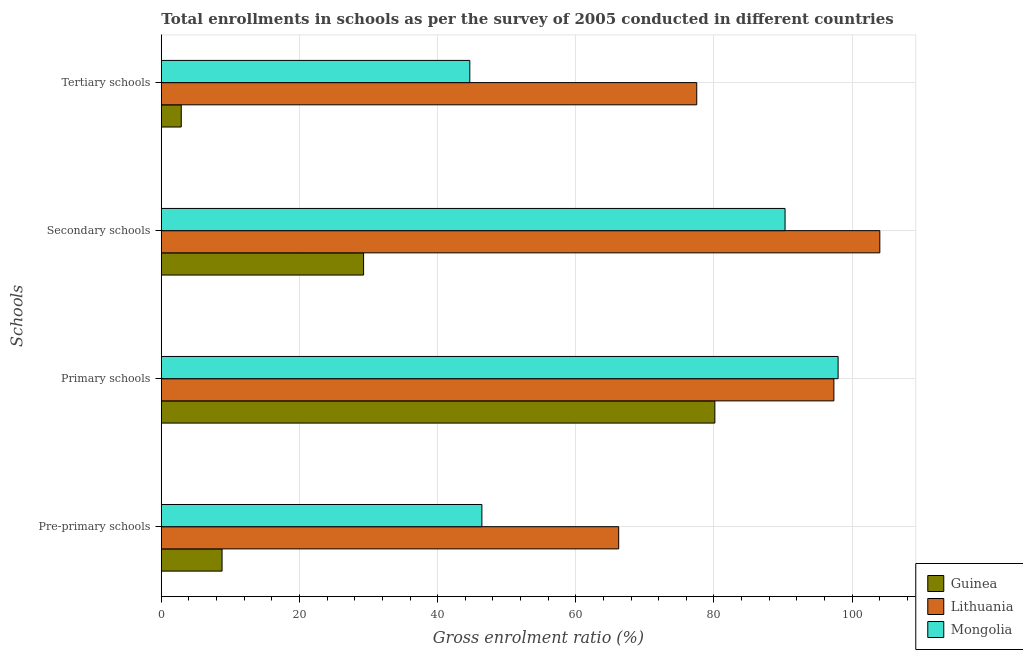How many different coloured bars are there?
Give a very brief answer. 3. Are the number of bars per tick equal to the number of legend labels?
Your answer should be compact. Yes. How many bars are there on the 3rd tick from the top?
Your response must be concise. 3. How many bars are there on the 1st tick from the bottom?
Your answer should be compact. 3. What is the label of the 3rd group of bars from the top?
Your answer should be very brief. Primary schools. What is the gross enrolment ratio in primary schools in Guinea?
Provide a succinct answer. 80.13. Across all countries, what is the maximum gross enrolment ratio in secondary schools?
Keep it short and to the point. 104.01. Across all countries, what is the minimum gross enrolment ratio in primary schools?
Your response must be concise. 80.13. In which country was the gross enrolment ratio in primary schools maximum?
Make the answer very short. Mongolia. In which country was the gross enrolment ratio in primary schools minimum?
Your answer should be very brief. Guinea. What is the total gross enrolment ratio in pre-primary schools in the graph?
Keep it short and to the point. 121.41. What is the difference between the gross enrolment ratio in secondary schools in Guinea and that in Lithuania?
Provide a short and direct response. -74.73. What is the difference between the gross enrolment ratio in primary schools in Lithuania and the gross enrolment ratio in tertiary schools in Guinea?
Keep it short and to the point. 94.47. What is the average gross enrolment ratio in secondary schools per country?
Make the answer very short. 74.53. What is the difference between the gross enrolment ratio in pre-primary schools and gross enrolment ratio in tertiary schools in Guinea?
Provide a succinct answer. 5.91. In how many countries, is the gross enrolment ratio in pre-primary schools greater than 88 %?
Ensure brevity in your answer.  0. What is the ratio of the gross enrolment ratio in tertiary schools in Mongolia to that in Guinea?
Offer a very short reply. 15.48. Is the gross enrolment ratio in pre-primary schools in Guinea less than that in Mongolia?
Make the answer very short. Yes. Is the difference between the gross enrolment ratio in tertiary schools in Mongolia and Lithuania greater than the difference between the gross enrolment ratio in secondary schools in Mongolia and Lithuania?
Give a very brief answer. No. What is the difference between the highest and the second highest gross enrolment ratio in primary schools?
Give a very brief answer. 0.61. What is the difference between the highest and the lowest gross enrolment ratio in pre-primary schools?
Offer a very short reply. 57.41. What does the 3rd bar from the top in Primary schools represents?
Keep it short and to the point. Guinea. What does the 2nd bar from the bottom in Tertiary schools represents?
Keep it short and to the point. Lithuania. Is it the case that in every country, the sum of the gross enrolment ratio in pre-primary schools and gross enrolment ratio in primary schools is greater than the gross enrolment ratio in secondary schools?
Offer a terse response. Yes. Does the graph contain any zero values?
Give a very brief answer. No. Does the graph contain grids?
Provide a short and direct response. Yes. How many legend labels are there?
Offer a terse response. 3. What is the title of the graph?
Provide a succinct answer. Total enrollments in schools as per the survey of 2005 conducted in different countries. Does "China" appear as one of the legend labels in the graph?
Keep it short and to the point. No. What is the label or title of the X-axis?
Keep it short and to the point. Gross enrolment ratio (%). What is the label or title of the Y-axis?
Offer a terse response. Schools. What is the Gross enrolment ratio (%) of Guinea in Pre-primary schools?
Your answer should be compact. 8.79. What is the Gross enrolment ratio (%) of Lithuania in Pre-primary schools?
Ensure brevity in your answer.  66.21. What is the Gross enrolment ratio (%) in Mongolia in Pre-primary schools?
Offer a very short reply. 46.41. What is the Gross enrolment ratio (%) in Guinea in Primary schools?
Ensure brevity in your answer.  80.13. What is the Gross enrolment ratio (%) of Lithuania in Primary schools?
Offer a terse response. 97.36. What is the Gross enrolment ratio (%) in Mongolia in Primary schools?
Your answer should be compact. 97.97. What is the Gross enrolment ratio (%) of Guinea in Secondary schools?
Give a very brief answer. 29.28. What is the Gross enrolment ratio (%) of Lithuania in Secondary schools?
Keep it short and to the point. 104.01. What is the Gross enrolment ratio (%) in Mongolia in Secondary schools?
Keep it short and to the point. 90.29. What is the Gross enrolment ratio (%) of Guinea in Tertiary schools?
Make the answer very short. 2.89. What is the Gross enrolment ratio (%) in Lithuania in Tertiary schools?
Offer a very short reply. 77.51. What is the Gross enrolment ratio (%) in Mongolia in Tertiary schools?
Offer a very short reply. 44.66. Across all Schools, what is the maximum Gross enrolment ratio (%) in Guinea?
Your answer should be compact. 80.13. Across all Schools, what is the maximum Gross enrolment ratio (%) in Lithuania?
Ensure brevity in your answer.  104.01. Across all Schools, what is the maximum Gross enrolment ratio (%) in Mongolia?
Make the answer very short. 97.97. Across all Schools, what is the minimum Gross enrolment ratio (%) of Guinea?
Keep it short and to the point. 2.89. Across all Schools, what is the minimum Gross enrolment ratio (%) of Lithuania?
Ensure brevity in your answer.  66.21. Across all Schools, what is the minimum Gross enrolment ratio (%) in Mongolia?
Offer a very short reply. 44.66. What is the total Gross enrolment ratio (%) of Guinea in the graph?
Keep it short and to the point. 121.09. What is the total Gross enrolment ratio (%) in Lithuania in the graph?
Provide a succinct answer. 345.08. What is the total Gross enrolment ratio (%) of Mongolia in the graph?
Your answer should be compact. 279.32. What is the difference between the Gross enrolment ratio (%) of Guinea in Pre-primary schools and that in Primary schools?
Make the answer very short. -71.33. What is the difference between the Gross enrolment ratio (%) in Lithuania in Pre-primary schools and that in Primary schools?
Your answer should be very brief. -31.15. What is the difference between the Gross enrolment ratio (%) of Mongolia in Pre-primary schools and that in Primary schools?
Offer a terse response. -51.56. What is the difference between the Gross enrolment ratio (%) of Guinea in Pre-primary schools and that in Secondary schools?
Your response must be concise. -20.49. What is the difference between the Gross enrolment ratio (%) in Lithuania in Pre-primary schools and that in Secondary schools?
Your response must be concise. -37.8. What is the difference between the Gross enrolment ratio (%) of Mongolia in Pre-primary schools and that in Secondary schools?
Provide a succinct answer. -43.89. What is the difference between the Gross enrolment ratio (%) of Guinea in Pre-primary schools and that in Tertiary schools?
Your response must be concise. 5.91. What is the difference between the Gross enrolment ratio (%) in Lithuania in Pre-primary schools and that in Tertiary schools?
Your answer should be compact. -11.3. What is the difference between the Gross enrolment ratio (%) in Mongolia in Pre-primary schools and that in Tertiary schools?
Offer a terse response. 1.75. What is the difference between the Gross enrolment ratio (%) in Guinea in Primary schools and that in Secondary schools?
Offer a terse response. 50.85. What is the difference between the Gross enrolment ratio (%) of Lithuania in Primary schools and that in Secondary schools?
Your answer should be compact. -6.65. What is the difference between the Gross enrolment ratio (%) of Mongolia in Primary schools and that in Secondary schools?
Your response must be concise. 7.68. What is the difference between the Gross enrolment ratio (%) of Guinea in Primary schools and that in Tertiary schools?
Make the answer very short. 77.24. What is the difference between the Gross enrolment ratio (%) in Lithuania in Primary schools and that in Tertiary schools?
Make the answer very short. 19.85. What is the difference between the Gross enrolment ratio (%) in Mongolia in Primary schools and that in Tertiary schools?
Provide a succinct answer. 53.31. What is the difference between the Gross enrolment ratio (%) of Guinea in Secondary schools and that in Tertiary schools?
Keep it short and to the point. 26.4. What is the difference between the Gross enrolment ratio (%) in Lithuania in Secondary schools and that in Tertiary schools?
Provide a succinct answer. 26.5. What is the difference between the Gross enrolment ratio (%) in Mongolia in Secondary schools and that in Tertiary schools?
Ensure brevity in your answer.  45.63. What is the difference between the Gross enrolment ratio (%) in Guinea in Pre-primary schools and the Gross enrolment ratio (%) in Lithuania in Primary schools?
Offer a terse response. -88.57. What is the difference between the Gross enrolment ratio (%) in Guinea in Pre-primary schools and the Gross enrolment ratio (%) in Mongolia in Primary schools?
Offer a terse response. -89.18. What is the difference between the Gross enrolment ratio (%) of Lithuania in Pre-primary schools and the Gross enrolment ratio (%) of Mongolia in Primary schools?
Keep it short and to the point. -31.76. What is the difference between the Gross enrolment ratio (%) in Guinea in Pre-primary schools and the Gross enrolment ratio (%) in Lithuania in Secondary schools?
Your answer should be compact. -95.22. What is the difference between the Gross enrolment ratio (%) in Guinea in Pre-primary schools and the Gross enrolment ratio (%) in Mongolia in Secondary schools?
Your answer should be compact. -81.5. What is the difference between the Gross enrolment ratio (%) of Lithuania in Pre-primary schools and the Gross enrolment ratio (%) of Mongolia in Secondary schools?
Provide a short and direct response. -24.08. What is the difference between the Gross enrolment ratio (%) of Guinea in Pre-primary schools and the Gross enrolment ratio (%) of Lithuania in Tertiary schools?
Keep it short and to the point. -68.71. What is the difference between the Gross enrolment ratio (%) of Guinea in Pre-primary schools and the Gross enrolment ratio (%) of Mongolia in Tertiary schools?
Ensure brevity in your answer.  -35.86. What is the difference between the Gross enrolment ratio (%) in Lithuania in Pre-primary schools and the Gross enrolment ratio (%) in Mongolia in Tertiary schools?
Your answer should be very brief. 21.55. What is the difference between the Gross enrolment ratio (%) of Guinea in Primary schools and the Gross enrolment ratio (%) of Lithuania in Secondary schools?
Your answer should be very brief. -23.88. What is the difference between the Gross enrolment ratio (%) in Guinea in Primary schools and the Gross enrolment ratio (%) in Mongolia in Secondary schools?
Provide a succinct answer. -10.16. What is the difference between the Gross enrolment ratio (%) in Lithuania in Primary schools and the Gross enrolment ratio (%) in Mongolia in Secondary schools?
Ensure brevity in your answer.  7.07. What is the difference between the Gross enrolment ratio (%) in Guinea in Primary schools and the Gross enrolment ratio (%) in Lithuania in Tertiary schools?
Provide a succinct answer. 2.62. What is the difference between the Gross enrolment ratio (%) of Guinea in Primary schools and the Gross enrolment ratio (%) of Mongolia in Tertiary schools?
Offer a terse response. 35.47. What is the difference between the Gross enrolment ratio (%) in Lithuania in Primary schools and the Gross enrolment ratio (%) in Mongolia in Tertiary schools?
Your answer should be very brief. 52.7. What is the difference between the Gross enrolment ratio (%) of Guinea in Secondary schools and the Gross enrolment ratio (%) of Lithuania in Tertiary schools?
Keep it short and to the point. -48.23. What is the difference between the Gross enrolment ratio (%) of Guinea in Secondary schools and the Gross enrolment ratio (%) of Mongolia in Tertiary schools?
Your response must be concise. -15.38. What is the difference between the Gross enrolment ratio (%) in Lithuania in Secondary schools and the Gross enrolment ratio (%) in Mongolia in Tertiary schools?
Offer a terse response. 59.35. What is the average Gross enrolment ratio (%) in Guinea per Schools?
Your answer should be compact. 30.27. What is the average Gross enrolment ratio (%) of Lithuania per Schools?
Your response must be concise. 86.27. What is the average Gross enrolment ratio (%) in Mongolia per Schools?
Your answer should be very brief. 69.83. What is the difference between the Gross enrolment ratio (%) in Guinea and Gross enrolment ratio (%) in Lithuania in Pre-primary schools?
Keep it short and to the point. -57.41. What is the difference between the Gross enrolment ratio (%) in Guinea and Gross enrolment ratio (%) in Mongolia in Pre-primary schools?
Keep it short and to the point. -37.61. What is the difference between the Gross enrolment ratio (%) of Lithuania and Gross enrolment ratio (%) of Mongolia in Pre-primary schools?
Make the answer very short. 19.8. What is the difference between the Gross enrolment ratio (%) of Guinea and Gross enrolment ratio (%) of Lithuania in Primary schools?
Provide a succinct answer. -17.23. What is the difference between the Gross enrolment ratio (%) in Guinea and Gross enrolment ratio (%) in Mongolia in Primary schools?
Your answer should be compact. -17.84. What is the difference between the Gross enrolment ratio (%) in Lithuania and Gross enrolment ratio (%) in Mongolia in Primary schools?
Ensure brevity in your answer.  -0.61. What is the difference between the Gross enrolment ratio (%) in Guinea and Gross enrolment ratio (%) in Lithuania in Secondary schools?
Ensure brevity in your answer.  -74.73. What is the difference between the Gross enrolment ratio (%) of Guinea and Gross enrolment ratio (%) of Mongolia in Secondary schools?
Make the answer very short. -61.01. What is the difference between the Gross enrolment ratio (%) of Lithuania and Gross enrolment ratio (%) of Mongolia in Secondary schools?
Your answer should be compact. 13.72. What is the difference between the Gross enrolment ratio (%) of Guinea and Gross enrolment ratio (%) of Lithuania in Tertiary schools?
Offer a terse response. -74.62. What is the difference between the Gross enrolment ratio (%) of Guinea and Gross enrolment ratio (%) of Mongolia in Tertiary schools?
Ensure brevity in your answer.  -41.77. What is the difference between the Gross enrolment ratio (%) of Lithuania and Gross enrolment ratio (%) of Mongolia in Tertiary schools?
Provide a short and direct response. 32.85. What is the ratio of the Gross enrolment ratio (%) in Guinea in Pre-primary schools to that in Primary schools?
Your answer should be very brief. 0.11. What is the ratio of the Gross enrolment ratio (%) in Lithuania in Pre-primary schools to that in Primary schools?
Provide a short and direct response. 0.68. What is the ratio of the Gross enrolment ratio (%) of Mongolia in Pre-primary schools to that in Primary schools?
Provide a succinct answer. 0.47. What is the ratio of the Gross enrolment ratio (%) of Guinea in Pre-primary schools to that in Secondary schools?
Your answer should be very brief. 0.3. What is the ratio of the Gross enrolment ratio (%) of Lithuania in Pre-primary schools to that in Secondary schools?
Provide a short and direct response. 0.64. What is the ratio of the Gross enrolment ratio (%) in Mongolia in Pre-primary schools to that in Secondary schools?
Provide a short and direct response. 0.51. What is the ratio of the Gross enrolment ratio (%) in Guinea in Pre-primary schools to that in Tertiary schools?
Your answer should be compact. 3.05. What is the ratio of the Gross enrolment ratio (%) in Lithuania in Pre-primary schools to that in Tertiary schools?
Ensure brevity in your answer.  0.85. What is the ratio of the Gross enrolment ratio (%) of Mongolia in Pre-primary schools to that in Tertiary schools?
Your answer should be very brief. 1.04. What is the ratio of the Gross enrolment ratio (%) of Guinea in Primary schools to that in Secondary schools?
Ensure brevity in your answer.  2.74. What is the ratio of the Gross enrolment ratio (%) in Lithuania in Primary schools to that in Secondary schools?
Your answer should be compact. 0.94. What is the ratio of the Gross enrolment ratio (%) in Mongolia in Primary schools to that in Secondary schools?
Offer a terse response. 1.08. What is the ratio of the Gross enrolment ratio (%) of Guinea in Primary schools to that in Tertiary schools?
Your response must be concise. 27.77. What is the ratio of the Gross enrolment ratio (%) in Lithuania in Primary schools to that in Tertiary schools?
Keep it short and to the point. 1.26. What is the ratio of the Gross enrolment ratio (%) in Mongolia in Primary schools to that in Tertiary schools?
Provide a short and direct response. 2.19. What is the ratio of the Gross enrolment ratio (%) in Guinea in Secondary schools to that in Tertiary schools?
Provide a short and direct response. 10.15. What is the ratio of the Gross enrolment ratio (%) of Lithuania in Secondary schools to that in Tertiary schools?
Offer a very short reply. 1.34. What is the ratio of the Gross enrolment ratio (%) of Mongolia in Secondary schools to that in Tertiary schools?
Your answer should be compact. 2.02. What is the difference between the highest and the second highest Gross enrolment ratio (%) in Guinea?
Give a very brief answer. 50.85. What is the difference between the highest and the second highest Gross enrolment ratio (%) of Lithuania?
Provide a succinct answer. 6.65. What is the difference between the highest and the second highest Gross enrolment ratio (%) in Mongolia?
Offer a very short reply. 7.68. What is the difference between the highest and the lowest Gross enrolment ratio (%) of Guinea?
Offer a terse response. 77.24. What is the difference between the highest and the lowest Gross enrolment ratio (%) in Lithuania?
Ensure brevity in your answer.  37.8. What is the difference between the highest and the lowest Gross enrolment ratio (%) in Mongolia?
Give a very brief answer. 53.31. 